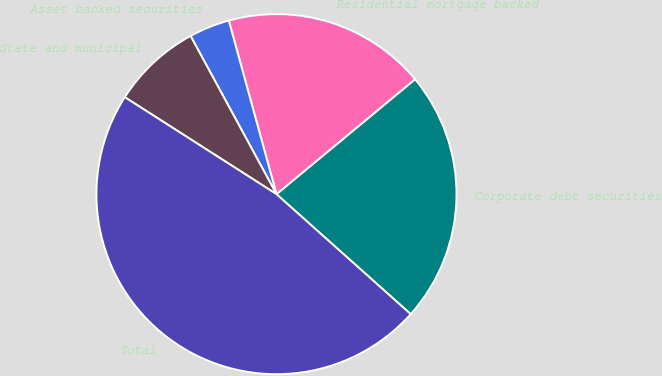Convert chart to OTSL. <chart><loc_0><loc_0><loc_500><loc_500><pie_chart><fcel>Corporate debt securities<fcel>Residential mortgage backed<fcel>Asset backed securities<fcel>State and municipal<fcel>Total<nl><fcel>22.63%<fcel>18.25%<fcel>3.65%<fcel>8.03%<fcel>47.45%<nl></chart> 